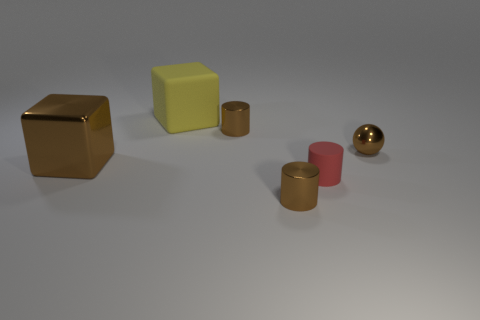What material is the small brown ball?
Your answer should be compact. Metal. There is a object in front of the red cylinder; what is its material?
Provide a short and direct response. Metal. Is there anything else that is the same color as the matte cylinder?
Make the answer very short. No. What is the size of the brown block that is the same material as the small sphere?
Keep it short and to the point. Large. How many large things are either blocks or brown metallic cubes?
Your response must be concise. 2. There is a cylinder to the left of the tiny metal thing in front of the metallic object left of the yellow cube; what is its size?
Your answer should be very brief. Small. What number of brown shiny objects are the same size as the brown metallic ball?
Offer a very short reply. 2. What number of objects are either large purple shiny objects or brown metal objects that are to the right of the yellow block?
Make the answer very short. 3. What is the shape of the small red object?
Ensure brevity in your answer.  Cylinder. Is the metal cube the same color as the sphere?
Give a very brief answer. Yes. 